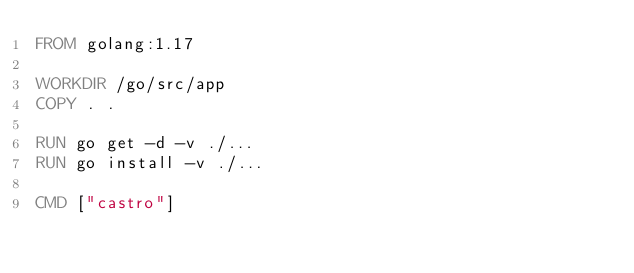Convert code to text. <code><loc_0><loc_0><loc_500><loc_500><_Dockerfile_>FROM golang:1.17

WORKDIR /go/src/app
COPY . .

RUN go get -d -v ./...
RUN go install -v ./...

CMD ["castro"]
</code> 